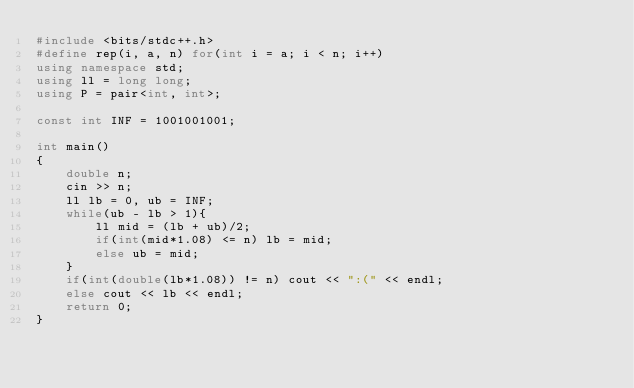Convert code to text. <code><loc_0><loc_0><loc_500><loc_500><_C++_>#include <bits/stdc++.h>
#define rep(i, a, n) for(int i = a; i < n; i++)
using namespace std;
using ll = long long;
using P = pair<int, int>;

const int INF = 1001001001;

int main()
{
    double n;
    cin >> n;
    ll lb = 0, ub = INF;
    while(ub - lb > 1){
        ll mid = (lb + ub)/2;
        if(int(mid*1.08) <= n) lb = mid;
        else ub = mid;
    }
    if(int(double(lb*1.08)) != n) cout << ":(" << endl;
    else cout << lb << endl;
    return 0;
}
</code> 